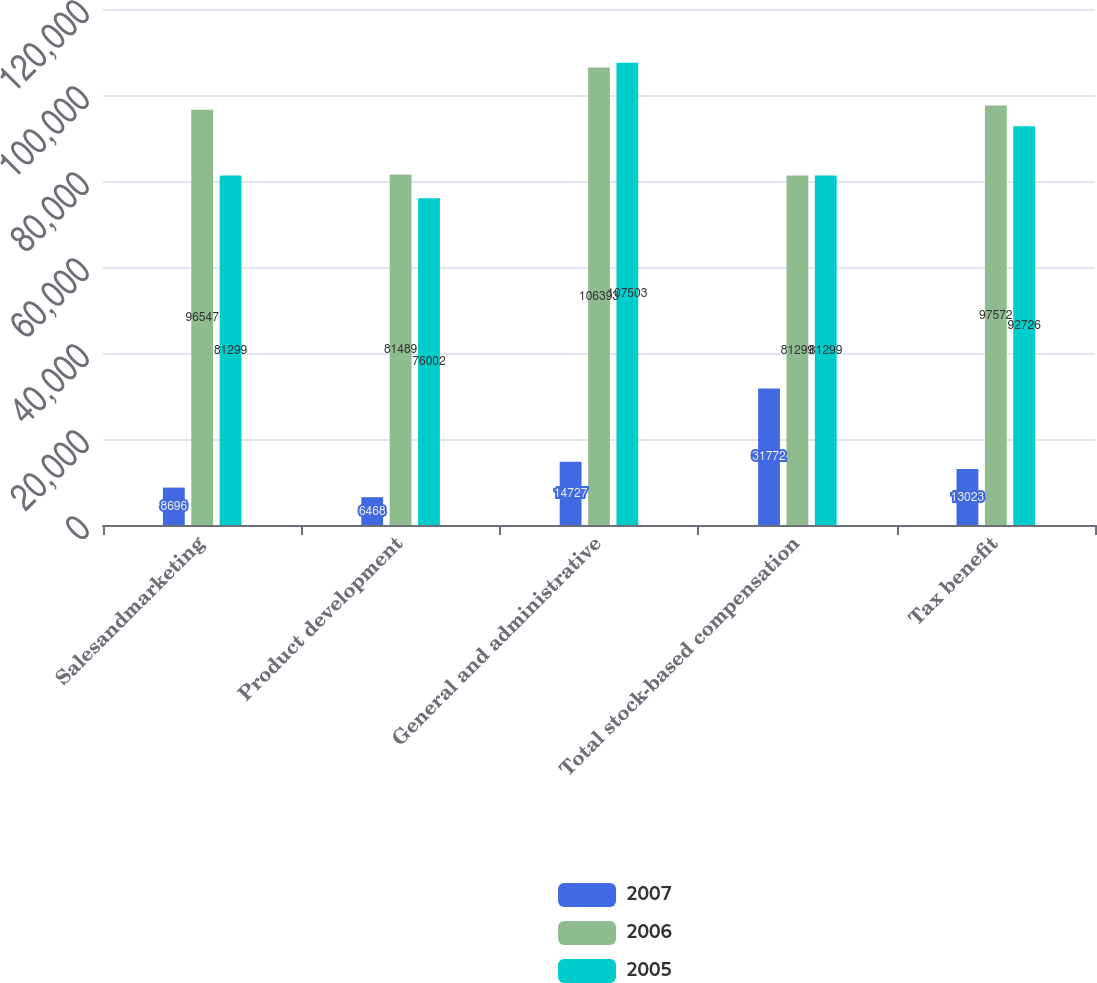Convert chart. <chart><loc_0><loc_0><loc_500><loc_500><stacked_bar_chart><ecel><fcel>Salesandmarketing<fcel>Product development<fcel>General and administrative<fcel>Total stock-based compensation<fcel>Tax benefit<nl><fcel>2007<fcel>8696<fcel>6468<fcel>14727<fcel>31772<fcel>13023<nl><fcel>2006<fcel>96547<fcel>81489<fcel>106393<fcel>81299<fcel>97572<nl><fcel>2005<fcel>81299<fcel>76002<fcel>107503<fcel>81299<fcel>92726<nl></chart> 